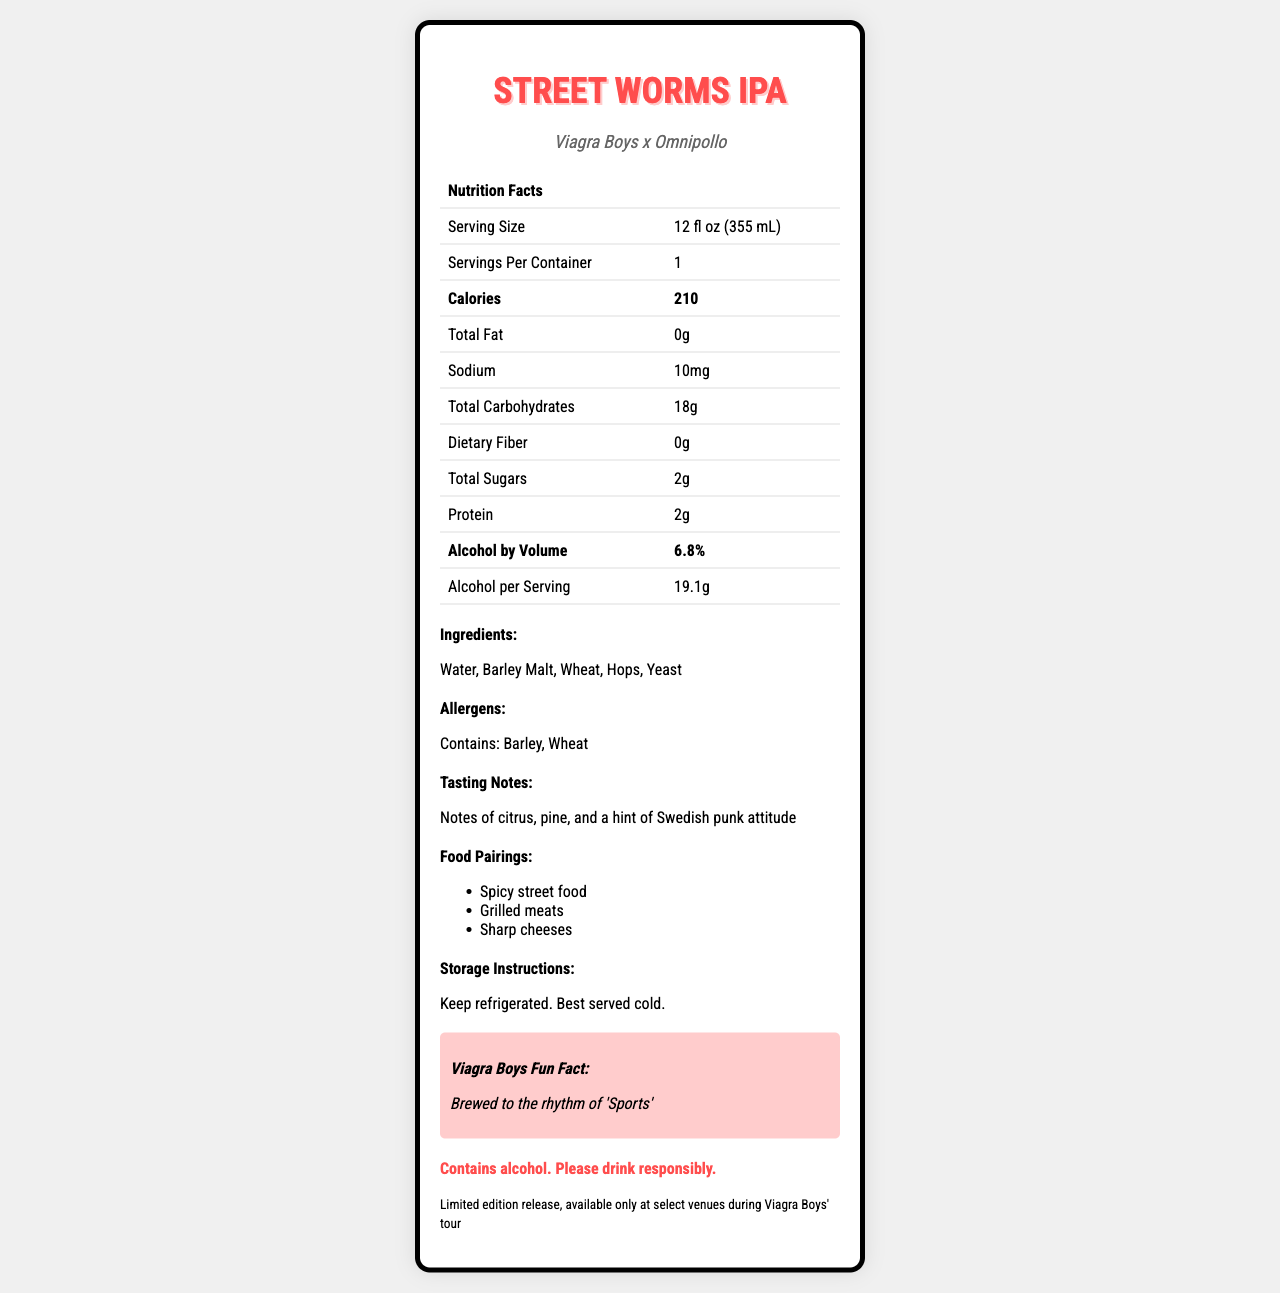what is the serving size? The serving size is directly stated in the document as 12 fl oz (355 mL).
Answer: 12 fl oz (355 mL) how much sodium does the Street Worms IPA contain? The sodium content is listed as 10mg in the nutrition facts section of the document.
Answer: 10mg what are the total carbohydrates per serving? The document states that the total carbohydrates per serving are 18g.
Answer: 18g list two ingredients in Street Worms IPA. The ingredients listed in the document are Water, Barley Malt, Wheat, Hops, and Yeast. Water and Barley Malt are two of these.
Answer: Water and Barley Malt what is the alcohol by volume (ABV) of Street Worms IPA? The alcohol by volume is clearly mentioned as 6.8% in the document.
Answer: 6.8% how many calories are there per serving? The document specifies that there are 210 calories per serving.
Answer: 210 what are the food pairings recommended for Street Worms IPA? The document mentions these food pairings in the food pairings section.
Answer: Spicy street food, grilled meats, and sharp cheeses which of the following is not an ingredient in Street Worms IPA? A. Barley Malt B. Rice C. Hops The document lists the ingredients as Water, Barley Malt, Wheat, Hops, and Yeast, and Rice is not among them.
Answer: B what interesting fact is related to Viagra Boys in the document? Under the section titled "Viagra Boys Fun Fact," it states that the beer is brewed to the rhythm of "Sports."
Answer: Brewed to the rhythm of "Sports" is Street Worms IPA caffeine-free? The document lists the caffeine content as 0mg, indicating that it is caffeine-free.
Answer: Yes describe the main idea of the document. The document is essentially an informative piece aiming to convey nutritional and other relevant details about the Street Worms IPA beer.
Answer: The document provides detailed nutrition facts and additional information about a collaborative craft beer named "Street Worms IPA," created by Viagra Boys and Omnipollo. It includes details such as serving size, calories, ingredients, allergens, tasting notes, and storage instructions. can you determine the shelf-life of Street Worms IPA from the document? The document does not provide any specific information about the shelf-life of the beer.
Answer: Not enough information 